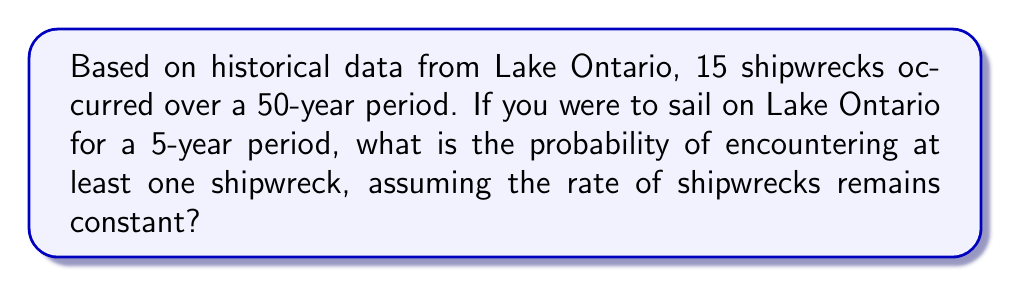What is the answer to this math problem? Let's approach this step-by-step:

1) First, we need to calculate the rate of shipwrecks per year:
   $$ \text{Rate} = \frac{15 \text{ shipwrecks}}{50 \text{ years}} = 0.3 \text{ shipwrecks/year} $$

2) For a 5-year period, the expected number of shipwrecks would be:
   $$ 0.3 \text{ shipwrecks/year} \times 5 \text{ years} = 1.5 \text{ shipwrecks} $$

3) We can model this as a Poisson process. The probability of exactly $k$ events occurring in a fixed interval of time when the expected number of events is $\lambda$ is given by the Poisson probability mass function:

   $$ P(X = k) = \frac{e^{-\lambda}\lambda^k}{k!} $$

4) We want the probability of at least one shipwreck, which is the same as 1 minus the probability of no shipwrecks. So we need to calculate:

   $$ P(X \geq 1) = 1 - P(X = 0) $$

5) Using the Poisson formula with $\lambda = 1.5$ and $k = 0$:

   $$ P(X = 0) = \frac{e^{-1.5}(1.5)^0}{0!} = e^{-1.5} \approx 0.2231 $$

6) Therefore, the probability of at least one shipwreck is:

   $$ P(X \geq 1) = 1 - 0.2231 \approx 0.7769 $$

7) Converting to a percentage:

   $$ 0.7769 \times 100\% \approx 77.69\% $$
Answer: 77.69% 